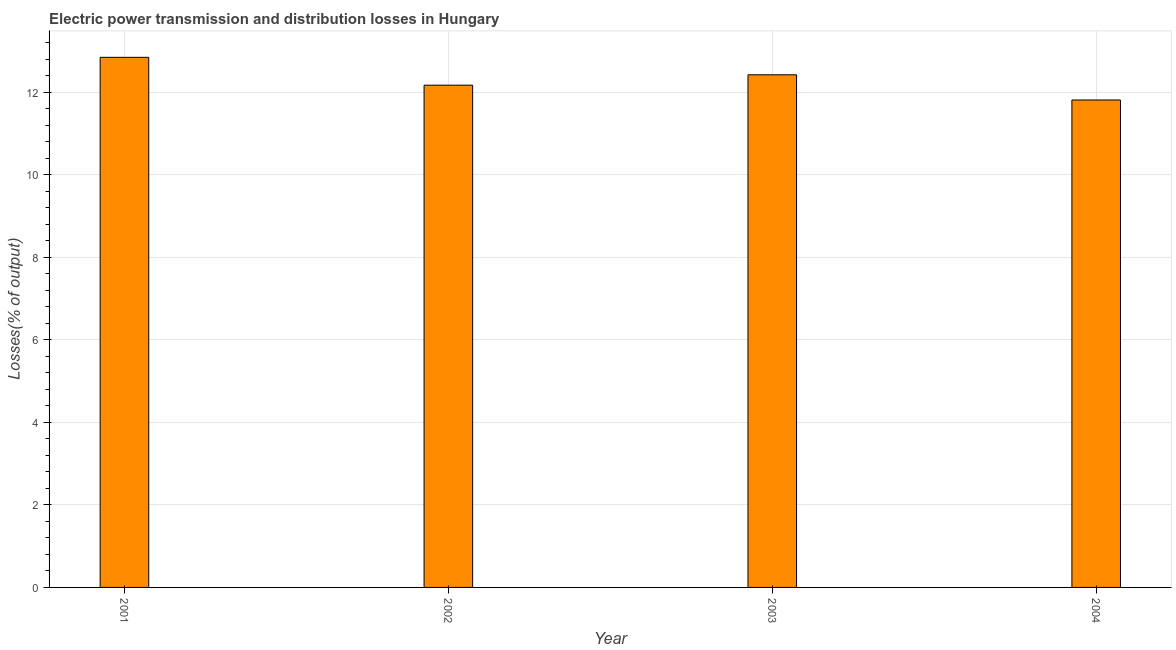Does the graph contain grids?
Offer a very short reply. Yes. What is the title of the graph?
Your answer should be very brief. Electric power transmission and distribution losses in Hungary. What is the label or title of the Y-axis?
Keep it short and to the point. Losses(% of output). What is the electric power transmission and distribution losses in 2001?
Offer a terse response. 12.84. Across all years, what is the maximum electric power transmission and distribution losses?
Offer a very short reply. 12.84. Across all years, what is the minimum electric power transmission and distribution losses?
Your response must be concise. 11.81. In which year was the electric power transmission and distribution losses minimum?
Your response must be concise. 2004. What is the sum of the electric power transmission and distribution losses?
Give a very brief answer. 49.23. What is the difference between the electric power transmission and distribution losses in 2002 and 2003?
Provide a short and direct response. -0.25. What is the average electric power transmission and distribution losses per year?
Provide a succinct answer. 12.31. What is the median electric power transmission and distribution losses?
Make the answer very short. 12.29. Do a majority of the years between 2002 and 2003 (inclusive) have electric power transmission and distribution losses greater than 7.6 %?
Make the answer very short. Yes. What is the ratio of the electric power transmission and distribution losses in 2002 to that in 2003?
Your response must be concise. 0.98. Is the electric power transmission and distribution losses in 2001 less than that in 2004?
Keep it short and to the point. No. What is the difference between the highest and the second highest electric power transmission and distribution losses?
Ensure brevity in your answer.  0.42. Is the sum of the electric power transmission and distribution losses in 2001 and 2004 greater than the maximum electric power transmission and distribution losses across all years?
Your response must be concise. Yes. In how many years, is the electric power transmission and distribution losses greater than the average electric power transmission and distribution losses taken over all years?
Your answer should be compact. 2. How many bars are there?
Offer a very short reply. 4. Are all the bars in the graph horizontal?
Your answer should be very brief. No. Are the values on the major ticks of Y-axis written in scientific E-notation?
Give a very brief answer. No. What is the Losses(% of output) of 2001?
Your answer should be very brief. 12.84. What is the Losses(% of output) of 2002?
Provide a succinct answer. 12.17. What is the Losses(% of output) of 2003?
Your answer should be compact. 12.42. What is the Losses(% of output) of 2004?
Give a very brief answer. 11.81. What is the difference between the Losses(% of output) in 2001 and 2002?
Make the answer very short. 0.67. What is the difference between the Losses(% of output) in 2001 and 2003?
Offer a very short reply. 0.42. What is the difference between the Losses(% of output) in 2001 and 2004?
Make the answer very short. 1.03. What is the difference between the Losses(% of output) in 2002 and 2003?
Provide a succinct answer. -0.25. What is the difference between the Losses(% of output) in 2002 and 2004?
Ensure brevity in your answer.  0.36. What is the difference between the Losses(% of output) in 2003 and 2004?
Your response must be concise. 0.61. What is the ratio of the Losses(% of output) in 2001 to that in 2002?
Offer a terse response. 1.05. What is the ratio of the Losses(% of output) in 2001 to that in 2003?
Your response must be concise. 1.03. What is the ratio of the Losses(% of output) in 2001 to that in 2004?
Your response must be concise. 1.09. What is the ratio of the Losses(% of output) in 2002 to that in 2003?
Your answer should be very brief. 0.98. What is the ratio of the Losses(% of output) in 2002 to that in 2004?
Offer a terse response. 1.03. What is the ratio of the Losses(% of output) in 2003 to that in 2004?
Provide a succinct answer. 1.05. 